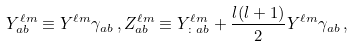<formula> <loc_0><loc_0><loc_500><loc_500>Y _ { a b } ^ { \ell m } \equiv Y ^ { \ell m } \gamma _ { a b } \, , Z ^ { \ell m } _ { a b } \equiv Y ^ { \ell m } _ { \colon a b } + \frac { l ( l + 1 ) } { 2 } Y ^ { \ell m } \gamma _ { a b } \, ,</formula> 